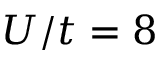Convert formula to latex. <formula><loc_0><loc_0><loc_500><loc_500>U / t = 8</formula> 